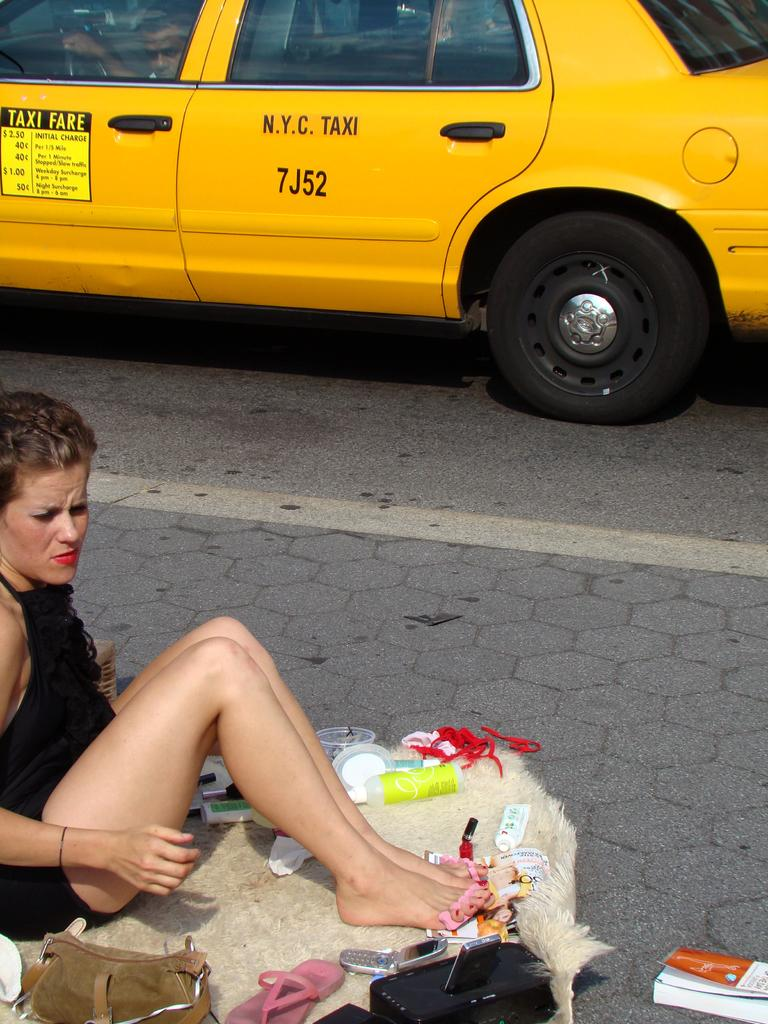<image>
Relay a brief, clear account of the picture shown. a lady next to a taxi with the word taxi on it 